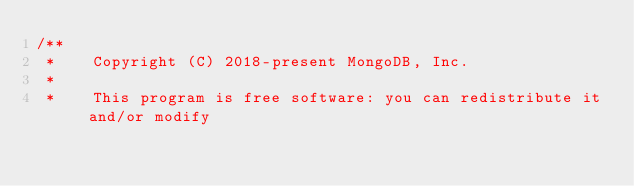Convert code to text. <code><loc_0><loc_0><loc_500><loc_500><_C++_>/**
 *    Copyright (C) 2018-present MongoDB, Inc.
 *
 *    This program is free software: you can redistribute it and/or modify</code> 